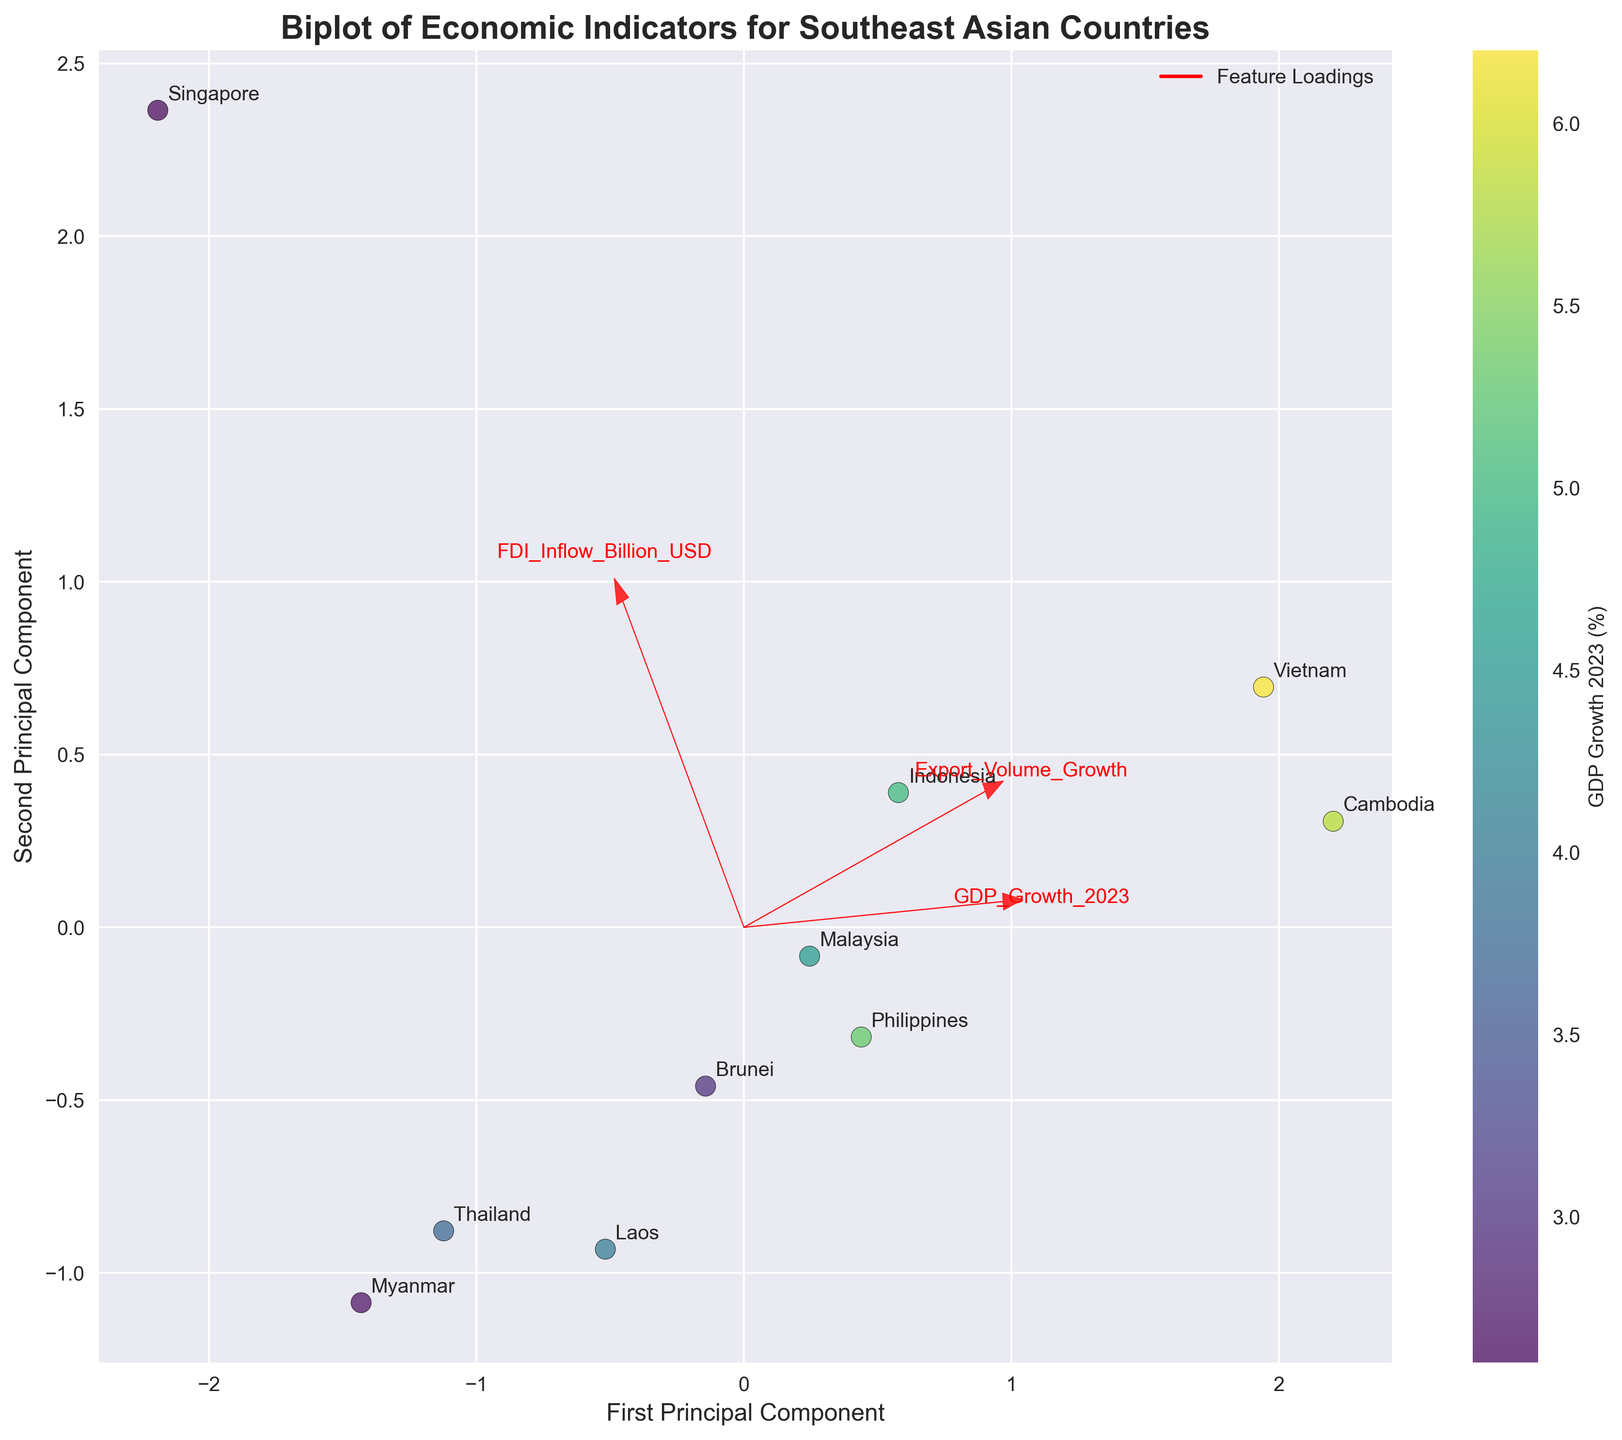1. What is the title of the plot? The title of the plot is displayed prominently at the top. By reading it, we can understand the general topic of the visualization before diving into specific details.
Answer: Biplot of Economic Indicators for Southeast Asian Countries 2. Which axis represents the First Principal Component? The axes in the plot are labeled. The axis with the label "First Principal Component" represents this dimension.
Answer: The horizontal axis 3. How many countries are represented in the plot? Each country is represented as a scatter point in the plot. By counting these points, we can determine the number of countries visualized.
Answer: 10 4. Which country has the highest GDP Growth 2023 according to the color gradient? The color gradient represents GDP Growth 2023, with different colors indicating different growth percentages. The brightest or most intense color typically signifies the highest value.
Answer: Vietnam 5. What points to the direction of higher Export Volume Growth in the plot? The loading vectors (arrows) in the plot indicate the direction of the original variables. The arrow pointing in the direction of higher values of Export Volume Growth shows the trend.
Answer: An arrow labeled "Export Volume Growth" 6. Which two countries are closest to each other in the PCA-transformed space, indicating similar economic profiles based on the three indicators? By observing the scatter points, we look for the pair of countries that are closest together in the PCA plot space. Closeness indicates similar profiles.
Answer: Cambodia and Vietnam 7. Compare Malaysia and Singapore based on their positions in the plot. Which country has higher export volume growth? We observe the positions of Malaysia and Singapore related to the "Export Volume Growth" loading vector. The country farther along this direction has higher export volume growth.
Answer: Malaysia 8. Which country is indicating the highest FDI Inflow according to the plot? FDI Inflow is represented by one of the loading vectors. The country whose scatter point aligns closely with the direction of this vector is indicative of the highest FDI inflow.
Answer: Singapore 9. How does Thailand compare to Laos in terms of the First Principal Component? By observing their positions on the horizontal axis, we can determine which country lies farther along the First Principal Component, indicating a higher score on this axis.
Answer: Thailand is higher 10. Which economic indicator contributes most to the First Principal Component based on the loading vectors' length? The length of the loading vector indicates the contribution strength of an economic indicator. By comparing lengths, we determine the most influential variable for the First Principal Component.
Answer: GDP_Growth_2023 